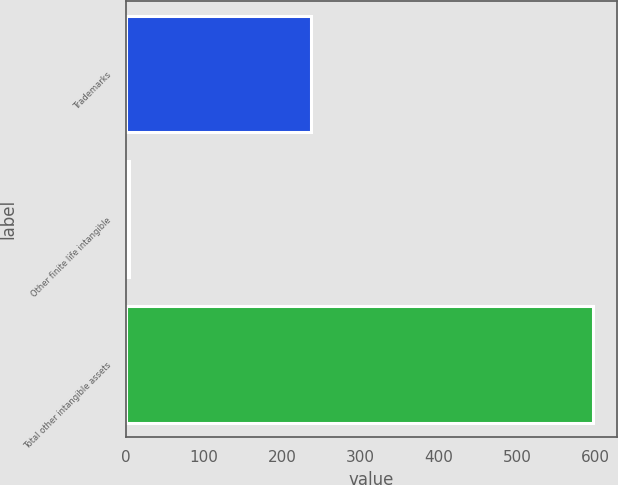Convert chart to OTSL. <chart><loc_0><loc_0><loc_500><loc_500><bar_chart><fcel>Trademarks<fcel>Other finite life intangible<fcel>Total other intangible assets<nl><fcel>236.9<fcel>3.2<fcel>597.6<nl></chart> 